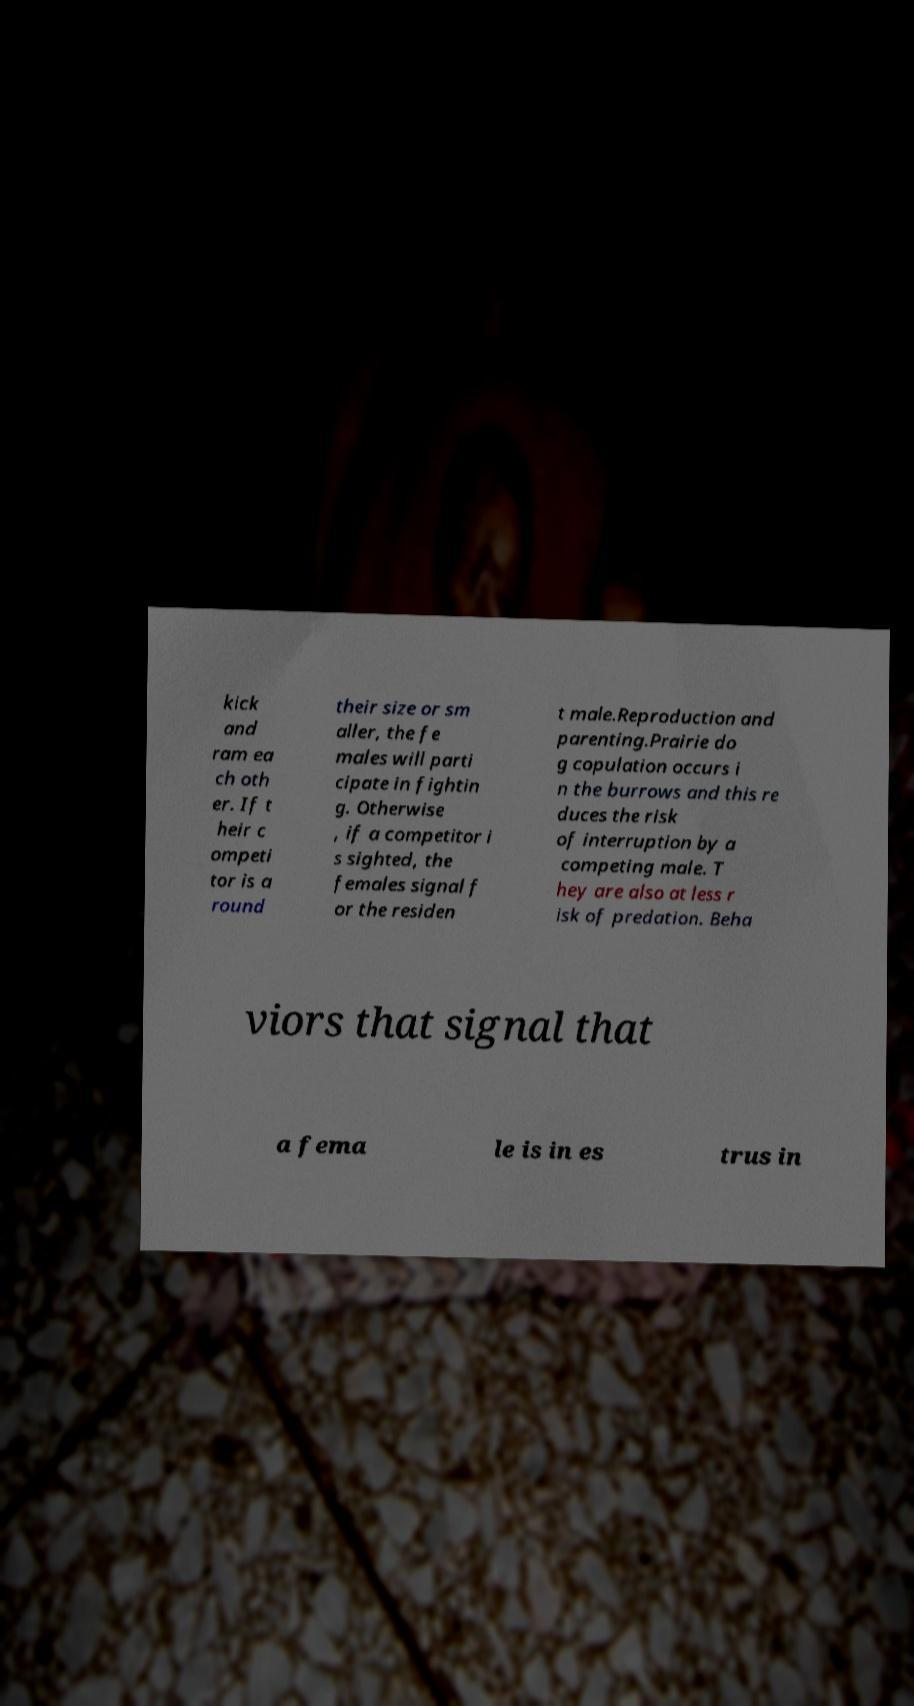There's text embedded in this image that I need extracted. Can you transcribe it verbatim? kick and ram ea ch oth er. If t heir c ompeti tor is a round their size or sm aller, the fe males will parti cipate in fightin g. Otherwise , if a competitor i s sighted, the females signal f or the residen t male.Reproduction and parenting.Prairie do g copulation occurs i n the burrows and this re duces the risk of interruption by a competing male. T hey are also at less r isk of predation. Beha viors that signal that a fema le is in es trus in 